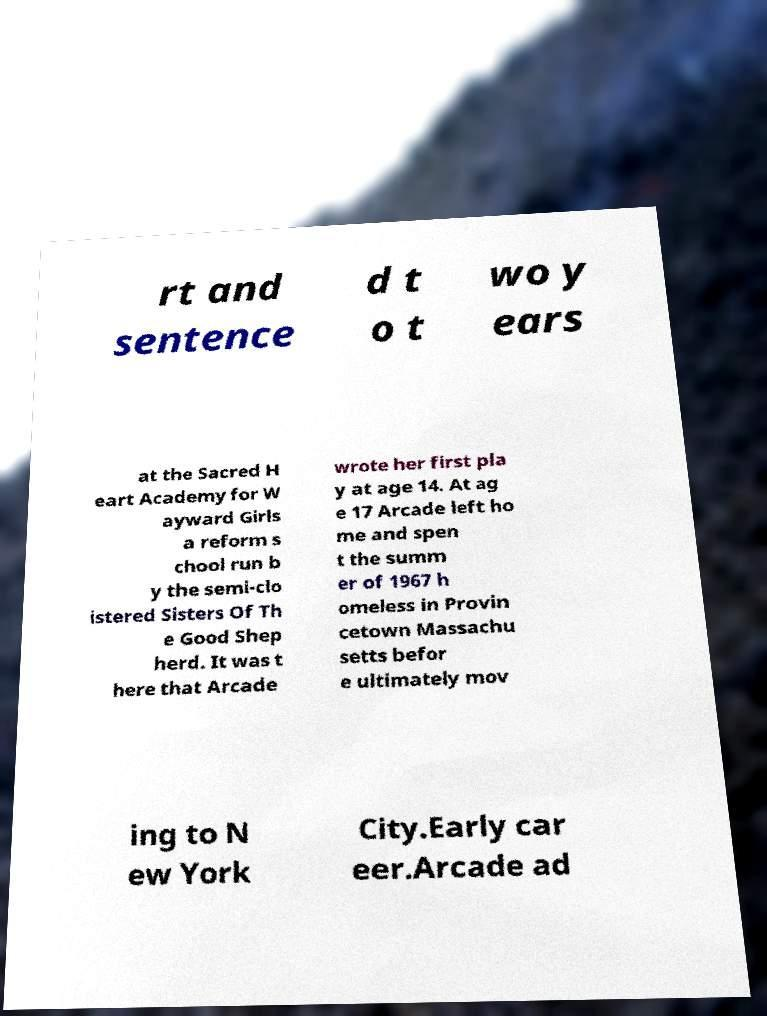Could you assist in decoding the text presented in this image and type it out clearly? rt and sentence d t o t wo y ears at the Sacred H eart Academy for W ayward Girls a reform s chool run b y the semi-clo istered Sisters Of Th e Good Shep herd. It was t here that Arcade wrote her first pla y at age 14. At ag e 17 Arcade left ho me and spen t the summ er of 1967 h omeless in Provin cetown Massachu setts befor e ultimately mov ing to N ew York City.Early car eer.Arcade ad 